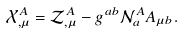<formula> <loc_0><loc_0><loc_500><loc_500>\mathcal { X } ^ { A } _ { , \mu } = \mathcal { Z } ^ { A } _ { , \mu } - g ^ { a b } \mathcal { N } ^ { A } _ { a } A _ { \mu b } .</formula> 